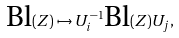<formula> <loc_0><loc_0><loc_500><loc_500>\text {Bl} ( Z ) \mapsto U _ { i } ^ { - 1 } \text {Bl} ( Z ) U _ { j } ,</formula> 